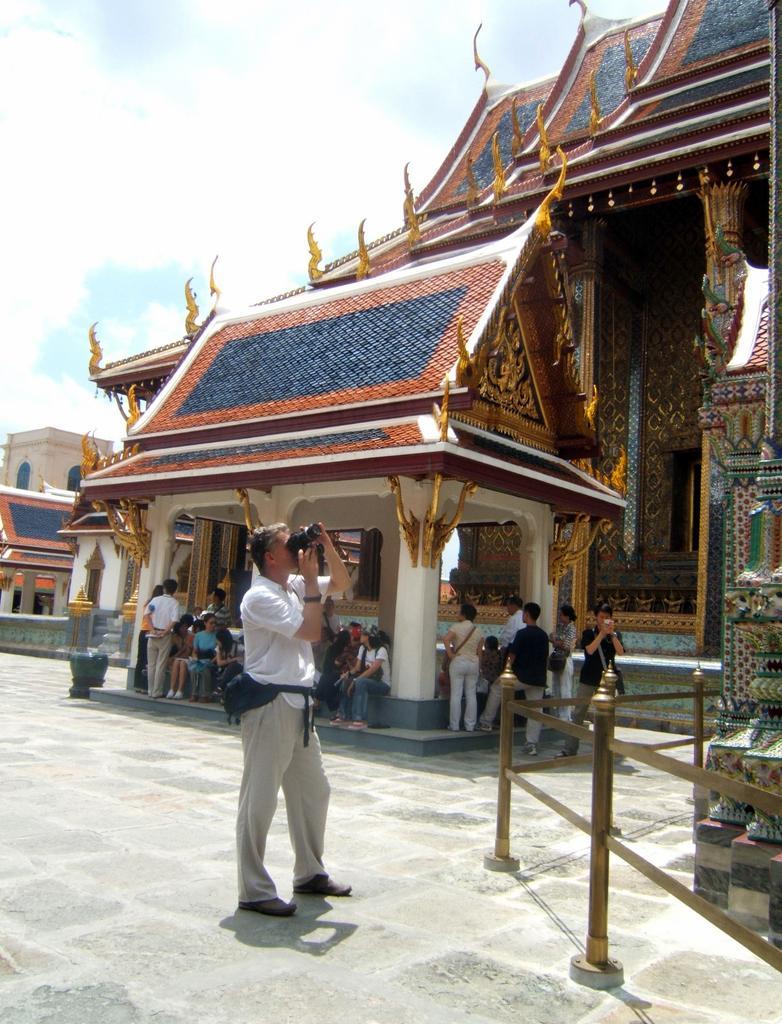In one or two sentences, can you explain what this image depicts? In the picture there is an architecture and a person is taking the photograph of that, behind him a lot of people were sitting under a roof. 